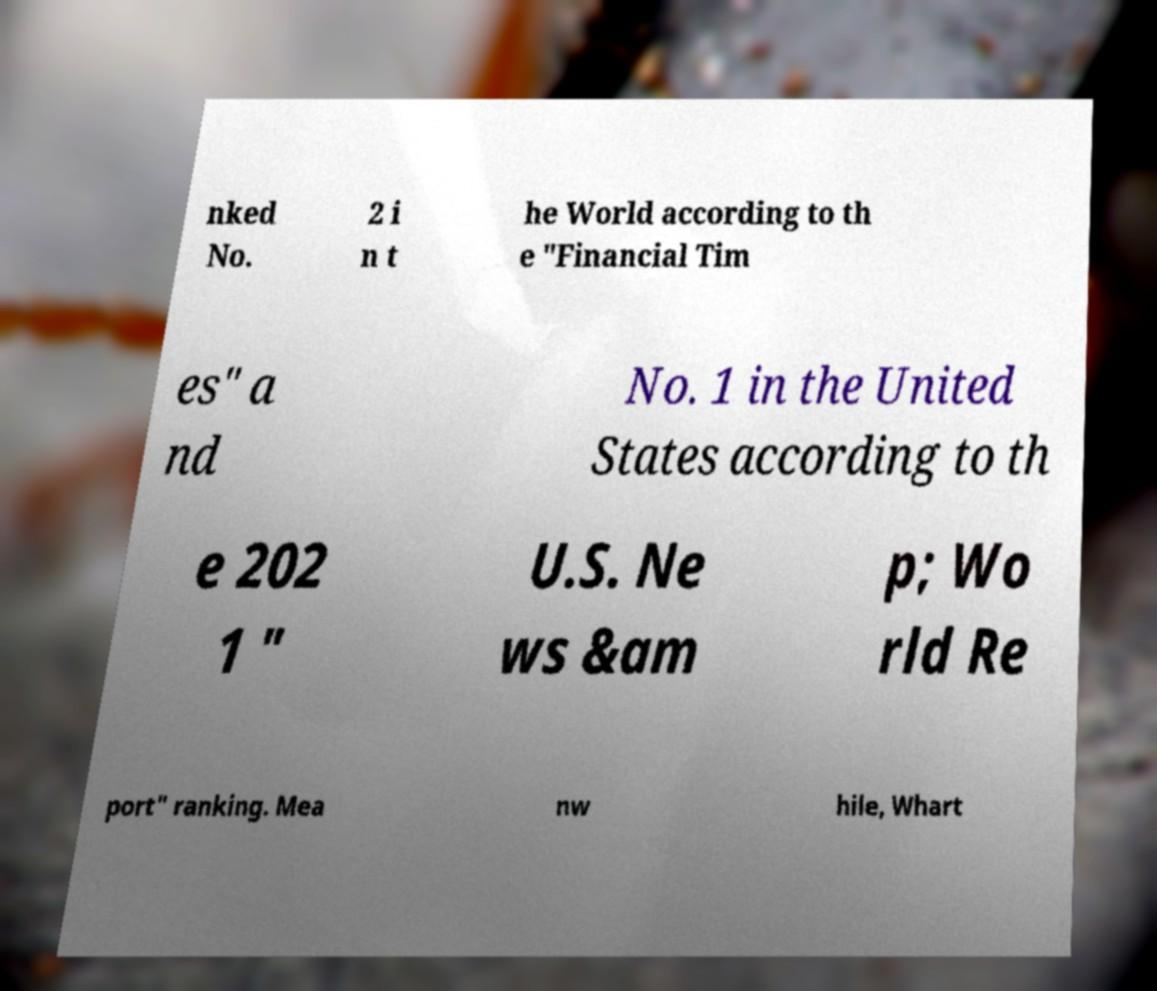There's text embedded in this image that I need extracted. Can you transcribe it verbatim? nked No. 2 i n t he World according to th e "Financial Tim es" a nd No. 1 in the United States according to th e 202 1 " U.S. Ne ws &am p; Wo rld Re port" ranking. Mea nw hile, Whart 